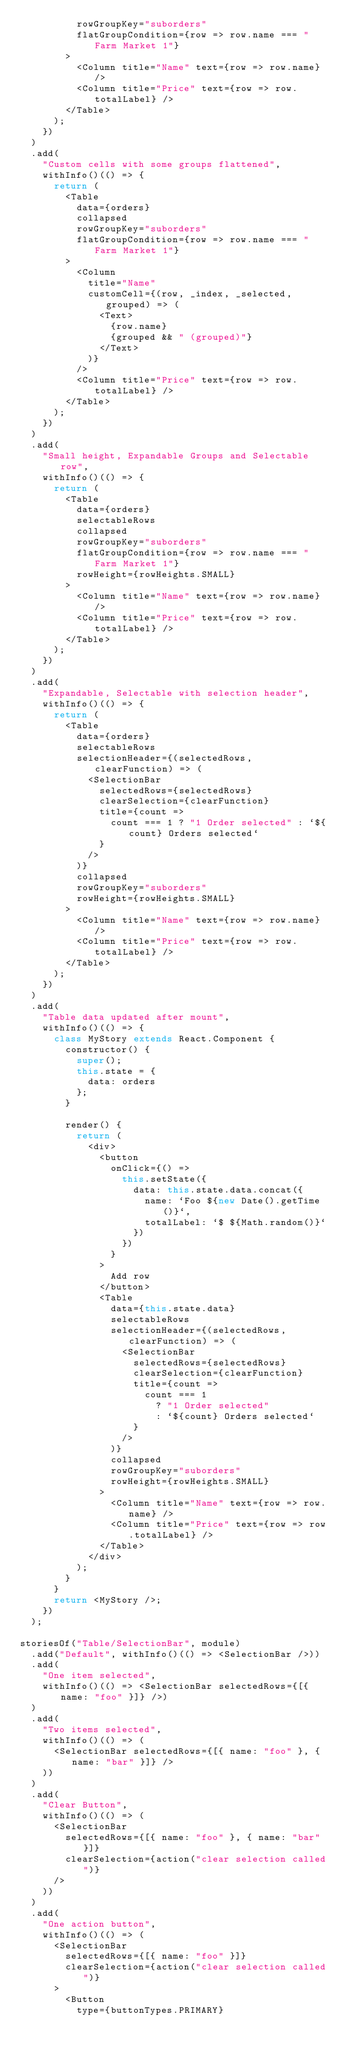Convert code to text. <code><loc_0><loc_0><loc_500><loc_500><_JavaScript_>          rowGroupKey="suborders"
          flatGroupCondition={row => row.name === "Farm Market 1"}
        >
          <Column title="Name" text={row => row.name} />
          <Column title="Price" text={row => row.totalLabel} />
        </Table>
      );
    })
  )
  .add(
    "Custom cells with some groups flattened",
    withInfo()(() => {
      return (
        <Table
          data={orders}
          collapsed
          rowGroupKey="suborders"
          flatGroupCondition={row => row.name === "Farm Market 1"}
        >
          <Column
            title="Name"
            customCell={(row, _index, _selected, grouped) => (
              <Text>
                {row.name}
                {grouped && " (grouped)"}
              </Text>
            )}
          />
          <Column title="Price" text={row => row.totalLabel} />
        </Table>
      );
    })
  )
  .add(
    "Small height, Expandable Groups and Selectable row",
    withInfo()(() => {
      return (
        <Table
          data={orders}
          selectableRows
          collapsed
          rowGroupKey="suborders"
          flatGroupCondition={row => row.name === "Farm Market 1"}
          rowHeight={rowHeights.SMALL}
        >
          <Column title="Name" text={row => row.name} />
          <Column title="Price" text={row => row.totalLabel} />
        </Table>
      );
    })
  )
  .add(
    "Expandable, Selectable with selection header",
    withInfo()(() => {
      return (
        <Table
          data={orders}
          selectableRows
          selectionHeader={(selectedRows, clearFunction) => (
            <SelectionBar
              selectedRows={selectedRows}
              clearSelection={clearFunction}
              title={count =>
                count === 1 ? "1 Order selected" : `${count} Orders selected`
              }
            />
          )}
          collapsed
          rowGroupKey="suborders"
          rowHeight={rowHeights.SMALL}
        >
          <Column title="Name" text={row => row.name} />
          <Column title="Price" text={row => row.totalLabel} />
        </Table>
      );
    })
  )
  .add(
    "Table data updated after mount",
    withInfo()(() => {
      class MyStory extends React.Component {
        constructor() {
          super();
          this.state = {
            data: orders
          };
        }

        render() {
          return (
            <div>
              <button
                onClick={() =>
                  this.setState({
                    data: this.state.data.concat({
                      name: `Foo ${new Date().getTime()}`,
                      totalLabel: `$ ${Math.random()}`
                    })
                  })
                }
              >
                Add row
              </button>
              <Table
                data={this.state.data}
                selectableRows
                selectionHeader={(selectedRows, clearFunction) => (
                  <SelectionBar
                    selectedRows={selectedRows}
                    clearSelection={clearFunction}
                    title={count =>
                      count === 1
                        ? "1 Order selected"
                        : `${count} Orders selected`
                    }
                  />
                )}
                collapsed
                rowGroupKey="suborders"
                rowHeight={rowHeights.SMALL}
              >
                <Column title="Name" text={row => row.name} />
                <Column title="Price" text={row => row.totalLabel} />
              </Table>
            </div>
          );
        }
      }
      return <MyStory />;
    })
  );

storiesOf("Table/SelectionBar", module)
  .add("Default", withInfo()(() => <SelectionBar />))
  .add(
    "One item selected",
    withInfo()(() => <SelectionBar selectedRows={[{ name: "foo" }]} />)
  )
  .add(
    "Two items selected",
    withInfo()(() => (
      <SelectionBar selectedRows={[{ name: "foo" }, { name: "bar" }]} />
    ))
  )
  .add(
    "Clear Button",
    withInfo()(() => (
      <SelectionBar
        selectedRows={[{ name: "foo" }, { name: "bar" }]}
        clearSelection={action("clear selection called")}
      />
    ))
  )
  .add(
    "One action button",
    withInfo()(() => (
      <SelectionBar
        selectedRows={[{ name: "foo" }]}
        clearSelection={action("clear selection called")}
      >
        <Button
          type={buttonTypes.PRIMARY}</code> 